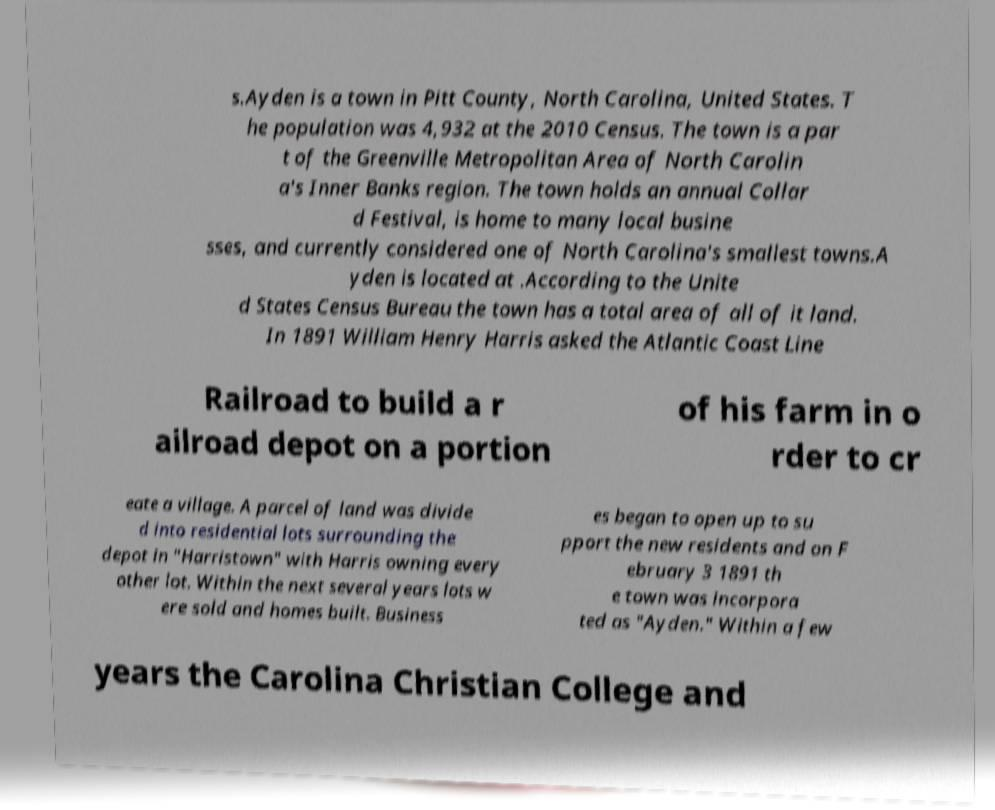Could you extract and type out the text from this image? s.Ayden is a town in Pitt County, North Carolina, United States. T he population was 4,932 at the 2010 Census. The town is a par t of the Greenville Metropolitan Area of North Carolin a's Inner Banks region. The town holds an annual Collar d Festival, is home to many local busine sses, and currently considered one of North Carolina's smallest towns.A yden is located at .According to the Unite d States Census Bureau the town has a total area of all of it land. In 1891 William Henry Harris asked the Atlantic Coast Line Railroad to build a r ailroad depot on a portion of his farm in o rder to cr eate a village. A parcel of land was divide d into residential lots surrounding the depot in "Harristown" with Harris owning every other lot. Within the next several years lots w ere sold and homes built. Business es began to open up to su pport the new residents and on F ebruary 3 1891 th e town was incorpora ted as "Ayden." Within a few years the Carolina Christian College and 